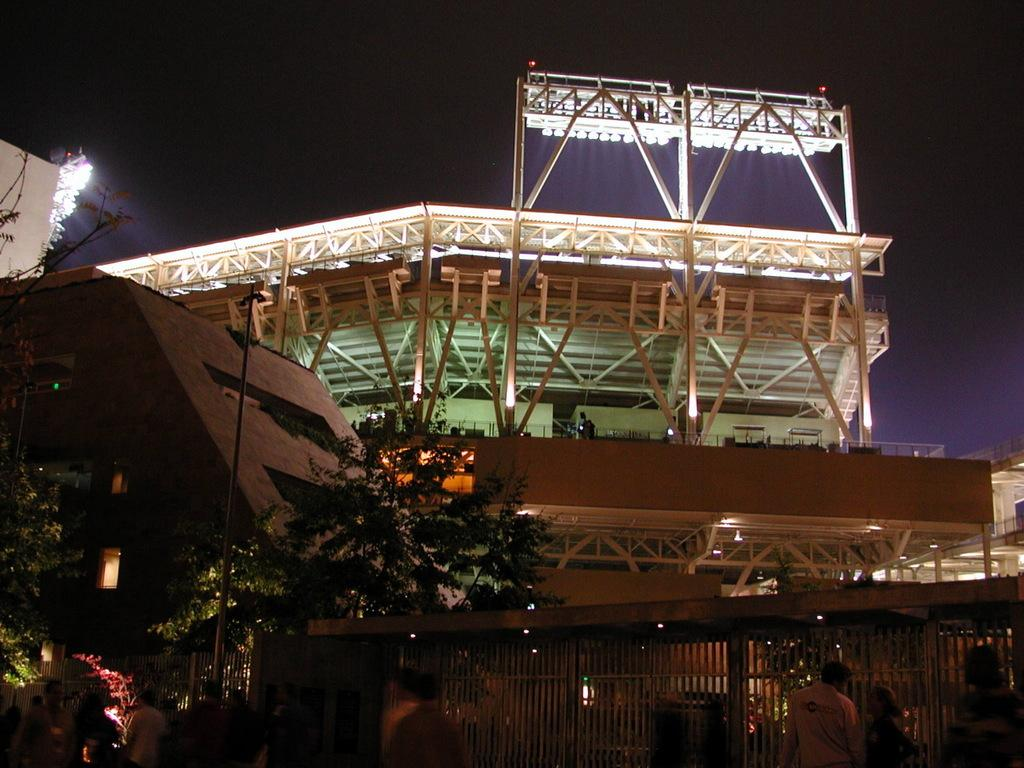What type of structure is visible in the image? There is a building in the image. What is placed on the roof of the building? Lights are arranged on the top of the roof. What can be seen in front of the building? There are trees in front of the building. What are some people doing near the fence? Some people are walking near the fence. What type of produce is being harvested from the worm in the image? There is no worm or produce present in the image. 